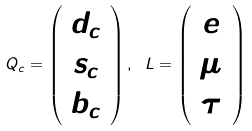Convert formula to latex. <formula><loc_0><loc_0><loc_500><loc_500>Q _ { c } = \left ( \begin{array} { c } d _ { c } \\ s _ { c } \\ b _ { c } \end{array} \right ) , \ L = \left ( \begin{array} { c } e \\ \mu \\ \tau \end{array} \right )</formula> 